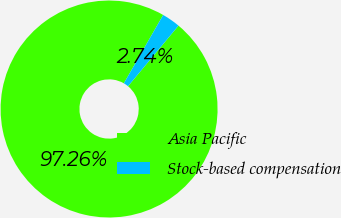<chart> <loc_0><loc_0><loc_500><loc_500><pie_chart><fcel>Asia Pacific<fcel>Stock-based compensation<nl><fcel>97.26%<fcel>2.74%<nl></chart> 